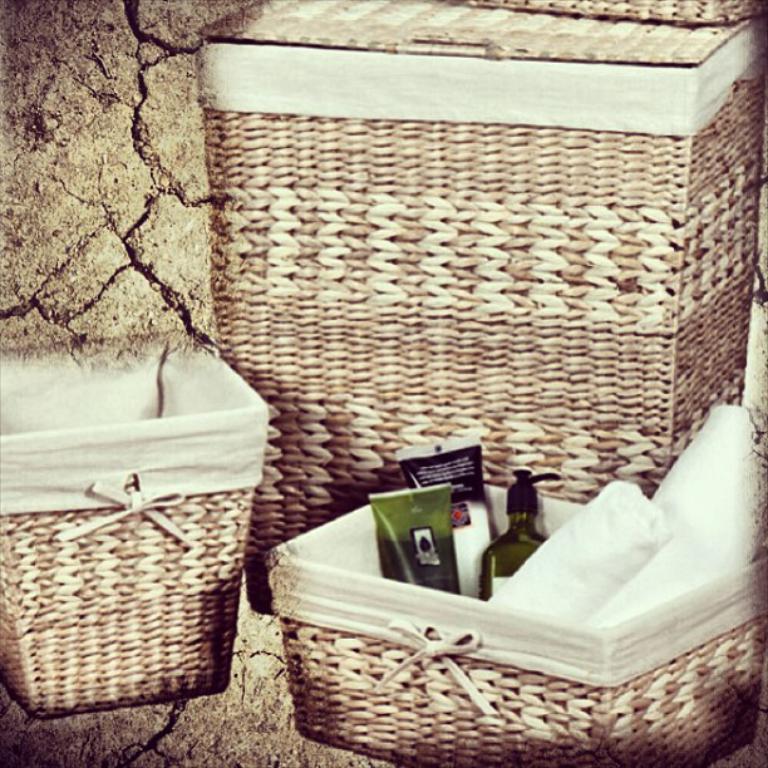Can you describe this image briefly? In this image I can see few baskets and I can see few bottles and few objects inside the basket. Background is in brown color. 